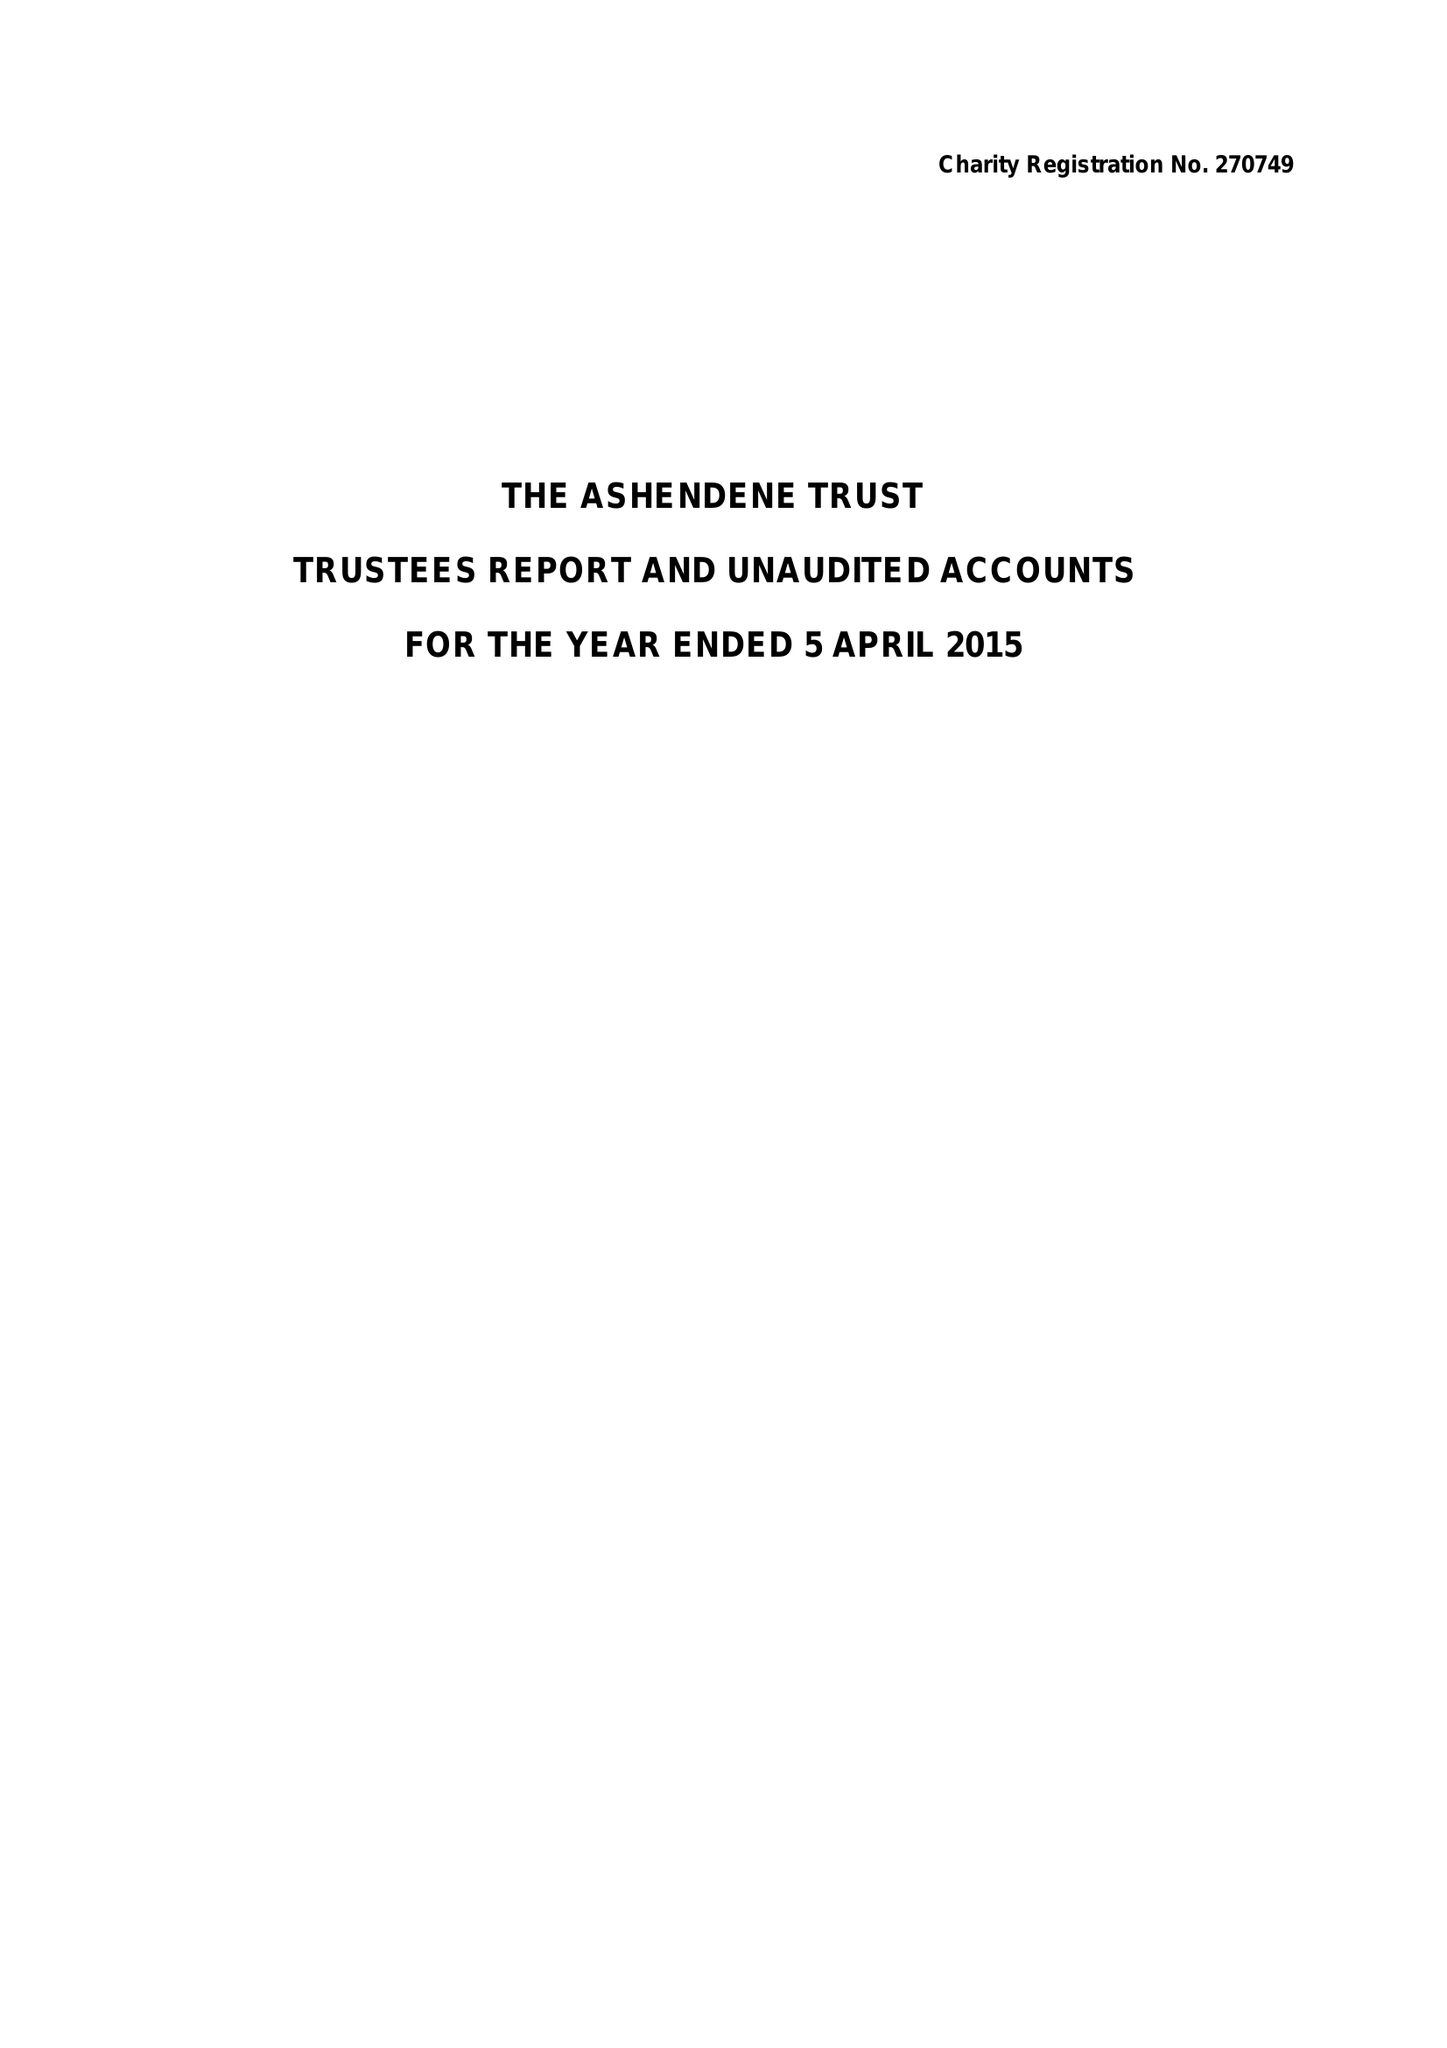What is the value for the charity_number?
Answer the question using a single word or phrase. 270749 